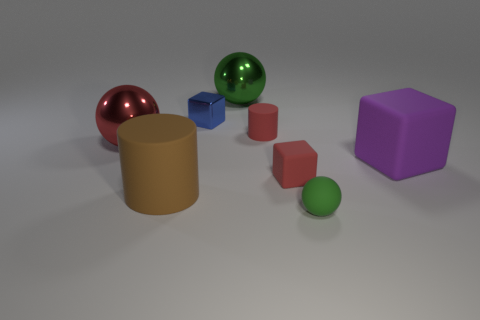Subtract all yellow blocks. How many green spheres are left? 2 Subtract 1 cubes. How many cubes are left? 2 Subtract all big green metal spheres. How many spheres are left? 2 Add 1 red metal objects. How many objects exist? 9 Subtract all balls. How many objects are left? 5 Subtract 0 green cubes. How many objects are left? 8 Subtract all cylinders. Subtract all large purple matte things. How many objects are left? 5 Add 8 tiny blue objects. How many tiny blue objects are left? 9 Add 2 large gray matte cubes. How many large gray matte cubes exist? 2 